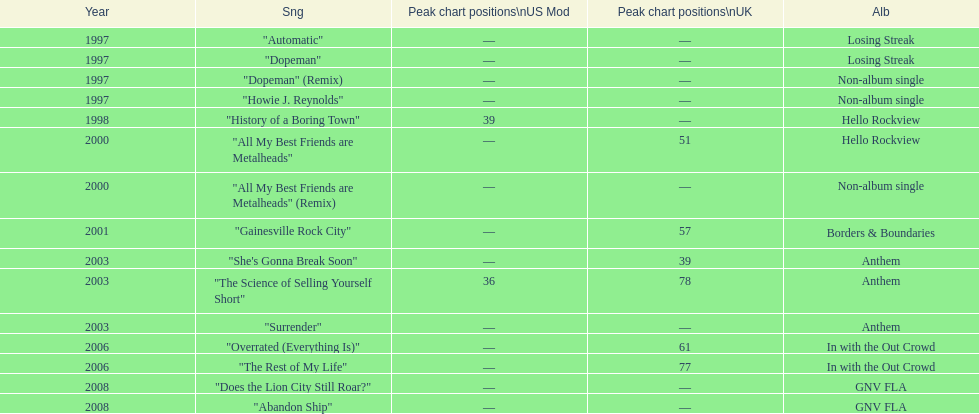Name one other single that was on the losing streak album besides "dopeman". "Automatic". 